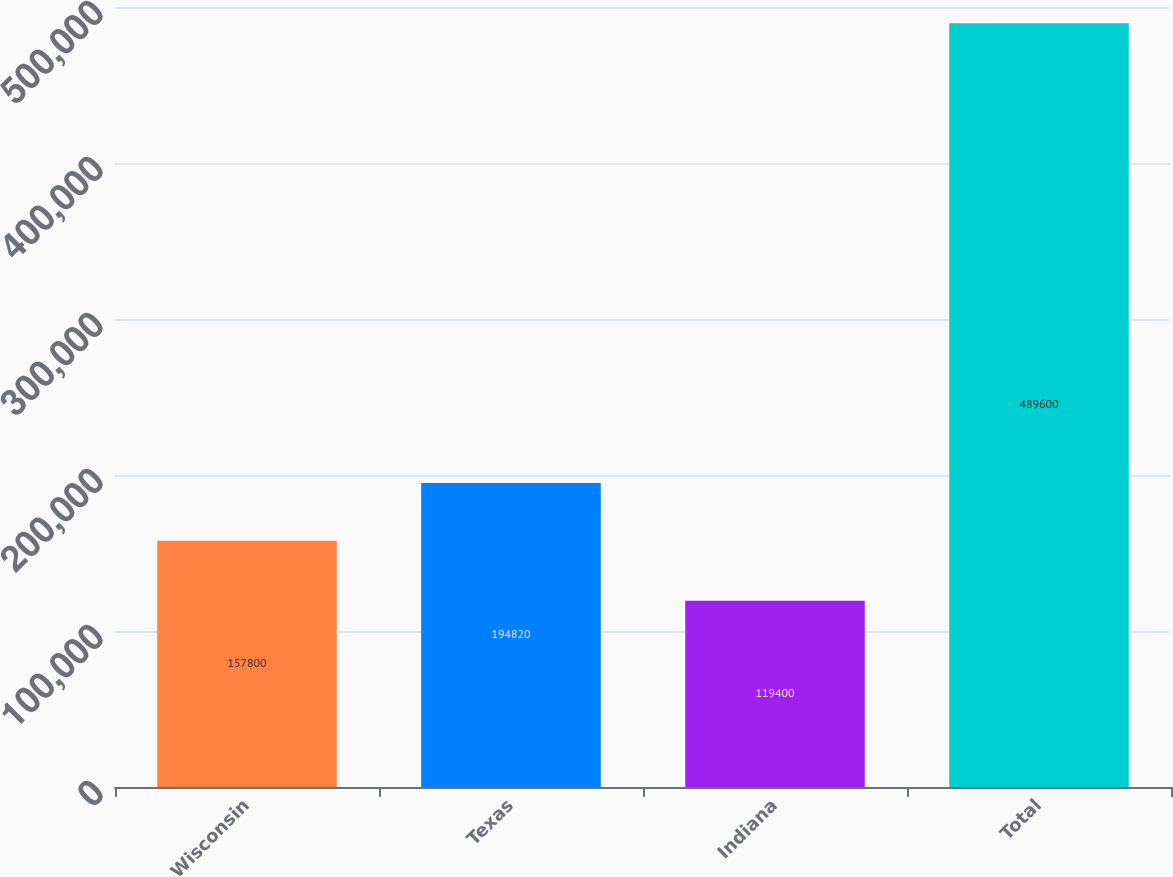Convert chart to OTSL. <chart><loc_0><loc_0><loc_500><loc_500><bar_chart><fcel>Wisconsin<fcel>Texas<fcel>Indiana<fcel>Total<nl><fcel>157800<fcel>194820<fcel>119400<fcel>489600<nl></chart> 